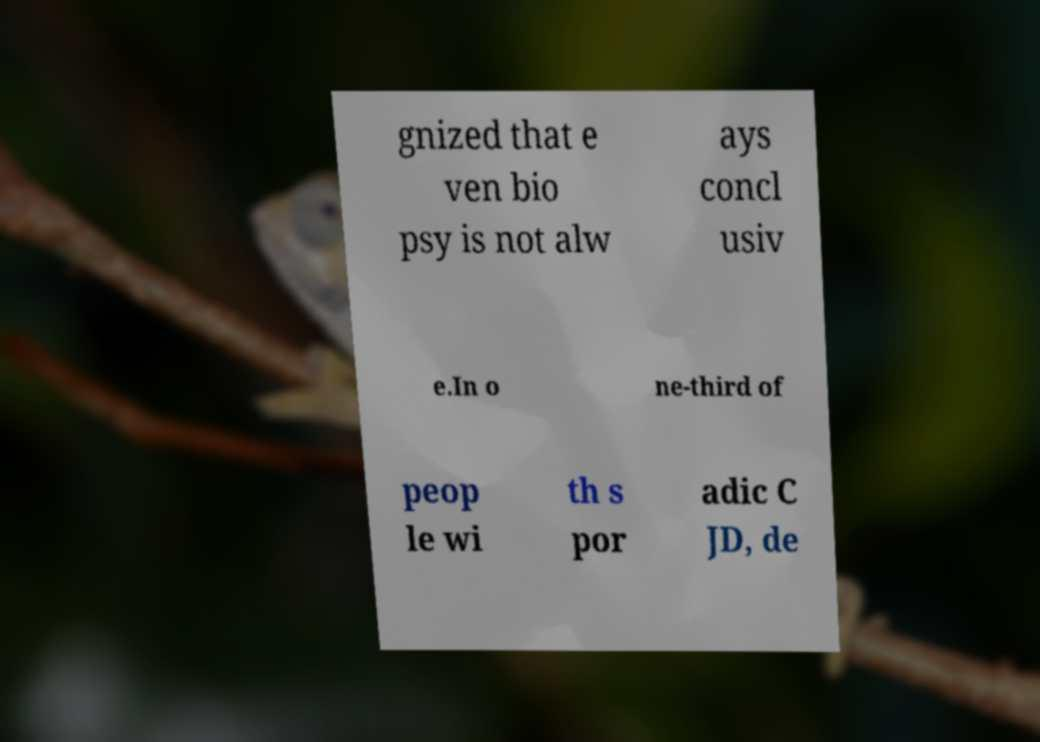What messages or text are displayed in this image? I need them in a readable, typed format. gnized that e ven bio psy is not alw ays concl usiv e.In o ne-third of peop le wi th s por adic C JD, de 